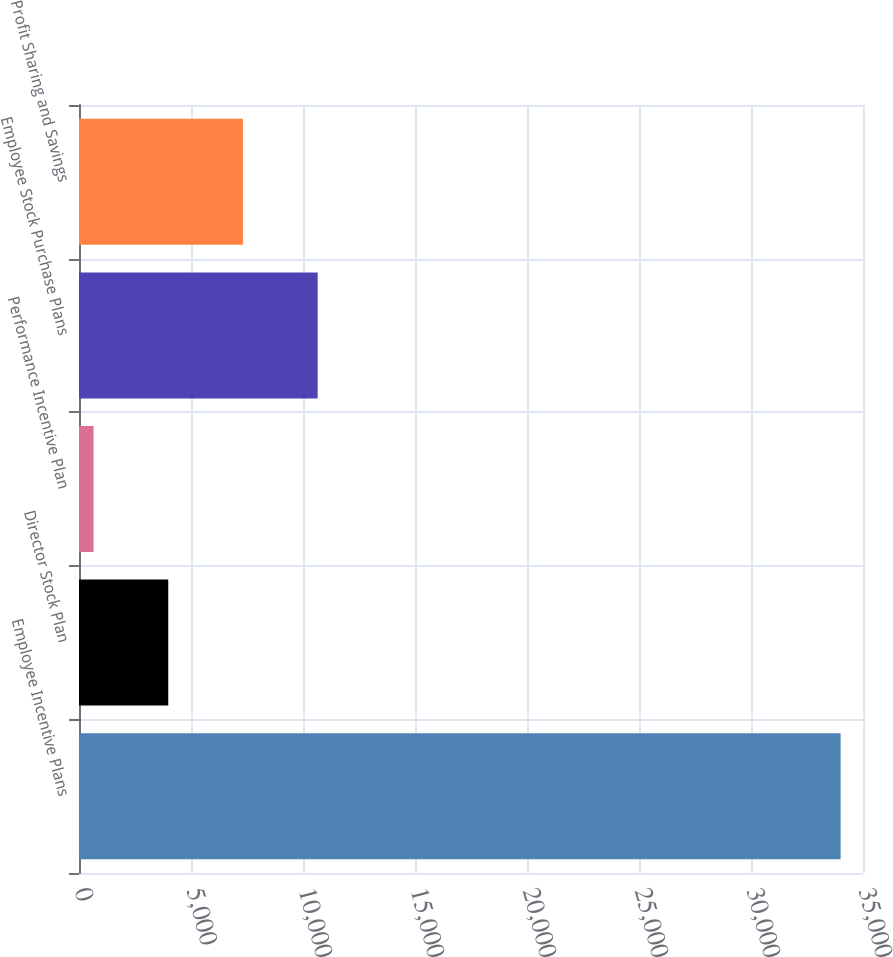<chart> <loc_0><loc_0><loc_500><loc_500><bar_chart><fcel>Employee Incentive Plans<fcel>Director Stock Plan<fcel>Performance Incentive Plan<fcel>Employee Stock Purchase Plans<fcel>Profit Sharing and Savings<nl><fcel>34000<fcel>3985<fcel>650<fcel>10655<fcel>7320<nl></chart> 